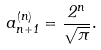<formula> <loc_0><loc_0><loc_500><loc_500>a ^ { ( n ) } _ { n + 1 } = \frac { 2 ^ { n } } { \sqrt { \pi } } .</formula> 